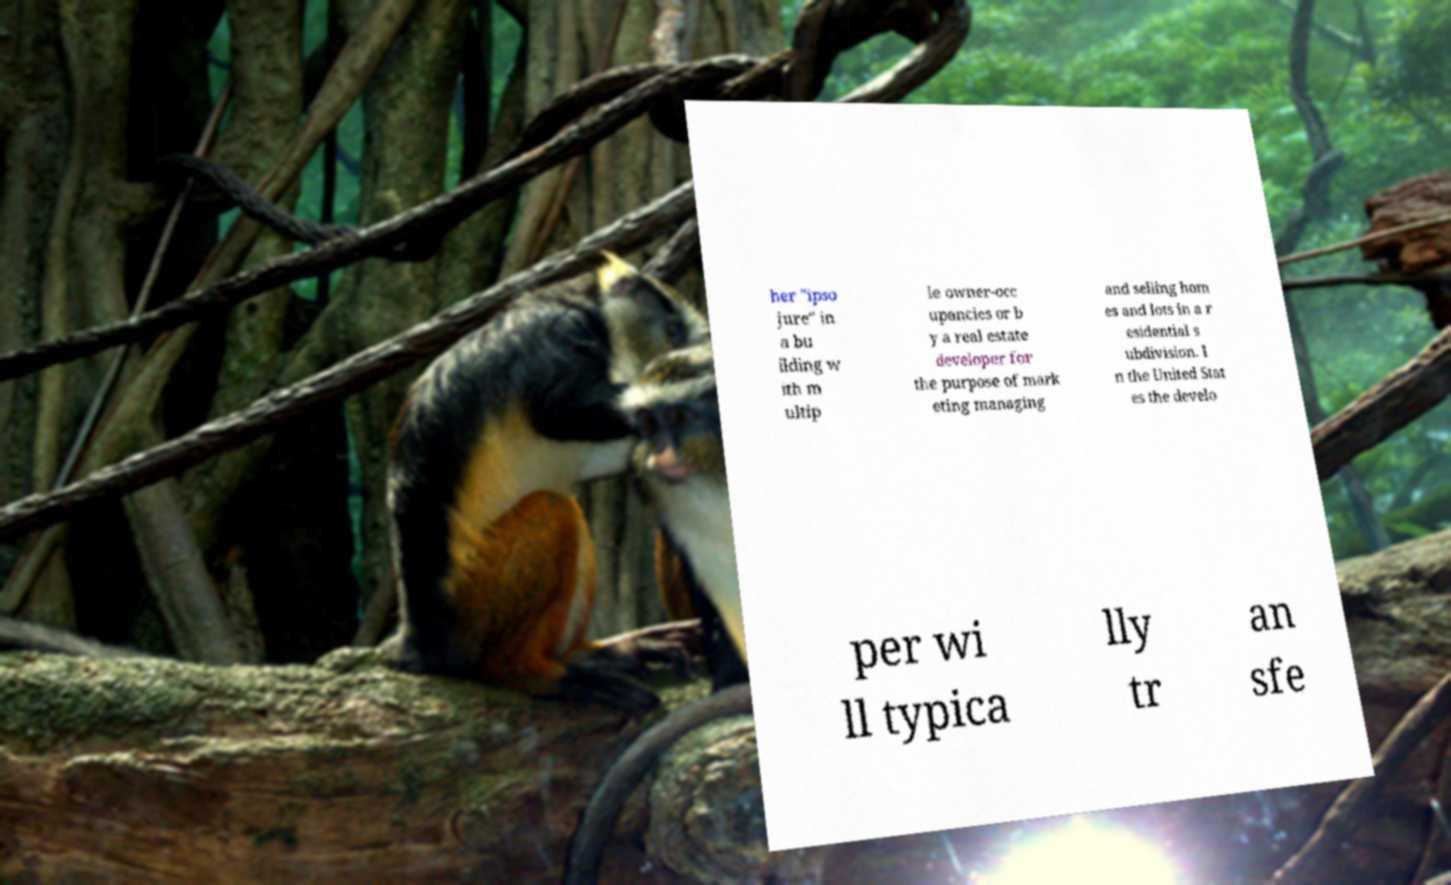Can you read and provide the text displayed in the image?This photo seems to have some interesting text. Can you extract and type it out for me? her "ipso jure" in a bu ilding w ith m ultip le owner-occ upancies or b y a real estate developer for the purpose of mark eting managing and selling hom es and lots in a r esidential s ubdivision. I n the United Stat es the develo per wi ll typica lly tr an sfe 